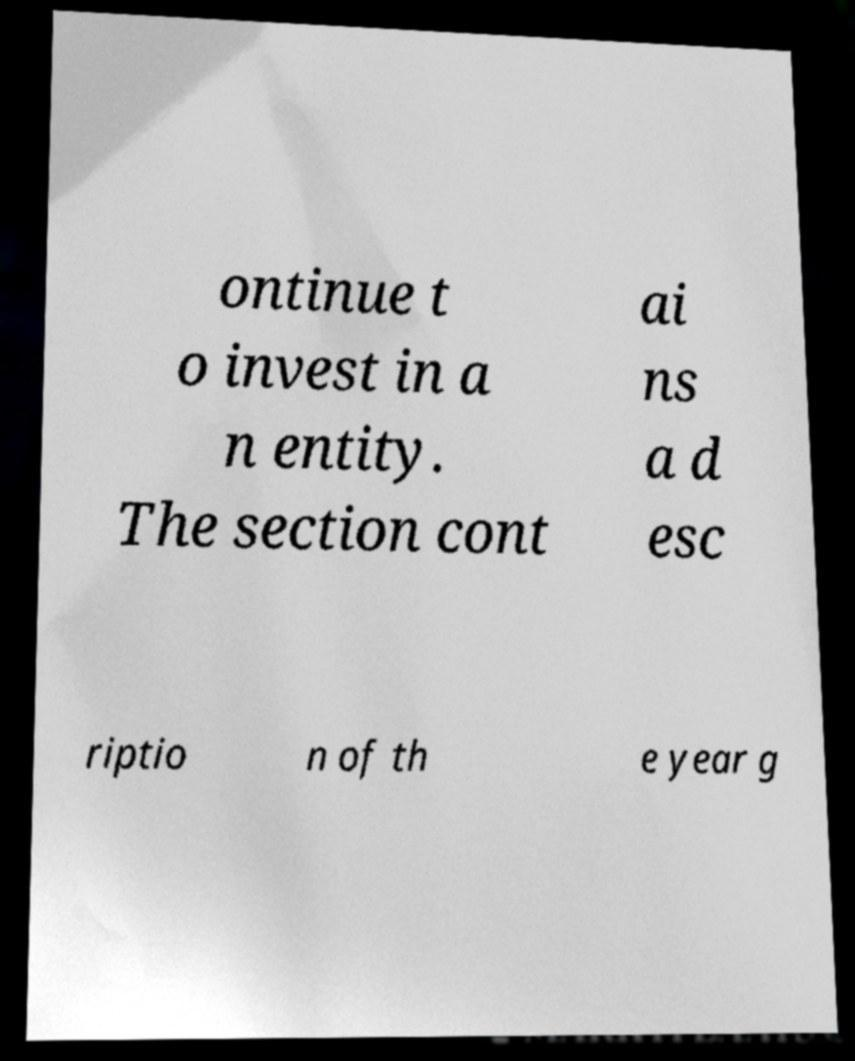What messages or text are displayed in this image? I need them in a readable, typed format. ontinue t o invest in a n entity. The section cont ai ns a d esc riptio n of th e year g 